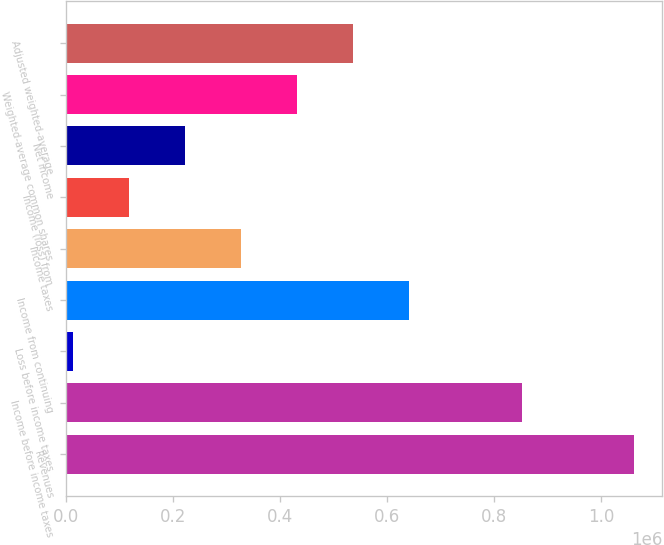Convert chart. <chart><loc_0><loc_0><loc_500><loc_500><bar_chart><fcel>Revenues<fcel>Income before income taxes<fcel>Loss before income taxes<fcel>Income from continuing<fcel>Income taxes<fcel>Income (loss) from<fcel>Net income<fcel>Weighted-average common shares<fcel>Adjusted weighted-average<nl><fcel>1.06096e+06<fcel>851341<fcel>12850<fcel>641718<fcel>327284<fcel>117661<fcel>222473<fcel>432096<fcel>536907<nl></chart> 